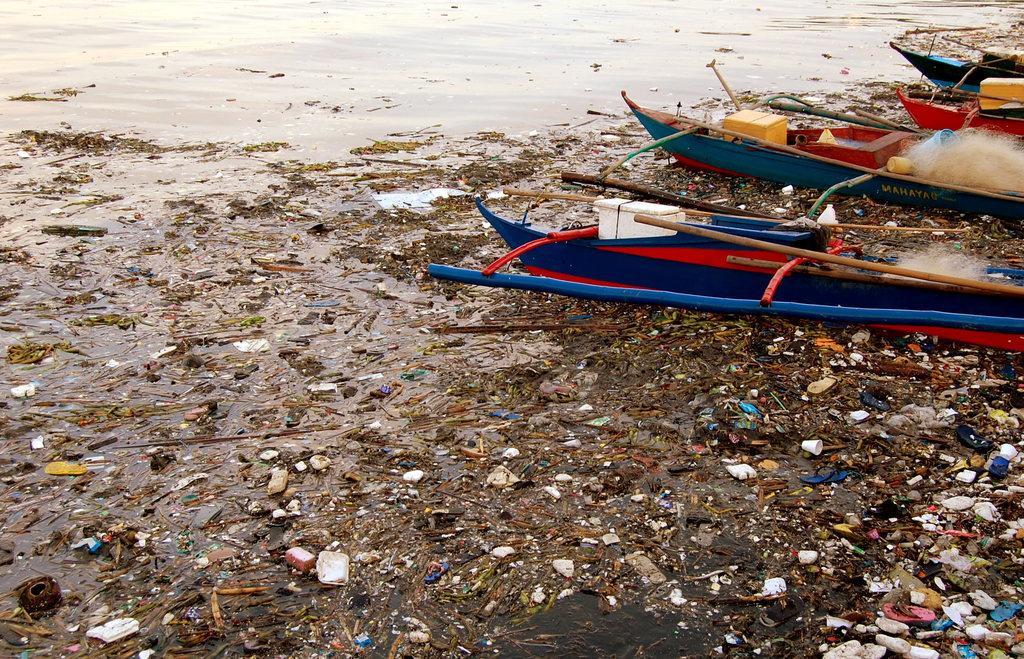Please provide a concise description of this image. In this picture we can see a water body. In the foreground of the water we can see lot of waste material. On the right there are boats. 